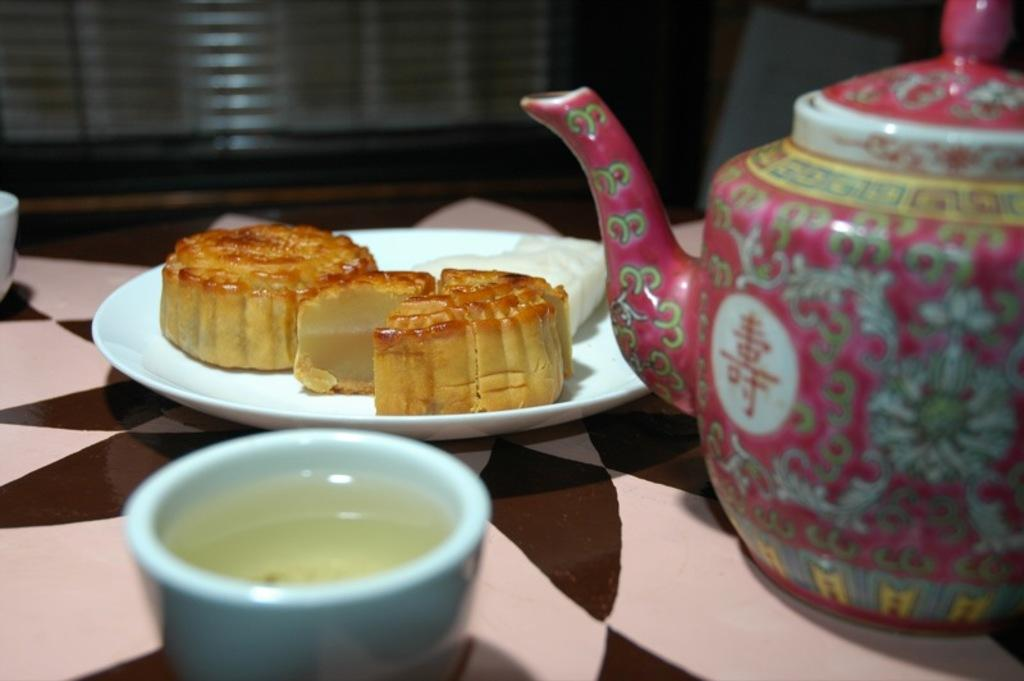What is the main object in the image? There is a kettle in the image. What else can be seen on the table in the image? There are sweets on a plate and a soup bowl on the table in the image. How many pies are visible in the image? There are no pies present in the image. What type of birds can be seen flying around the kettle in the image? There are no birds present in the image. 